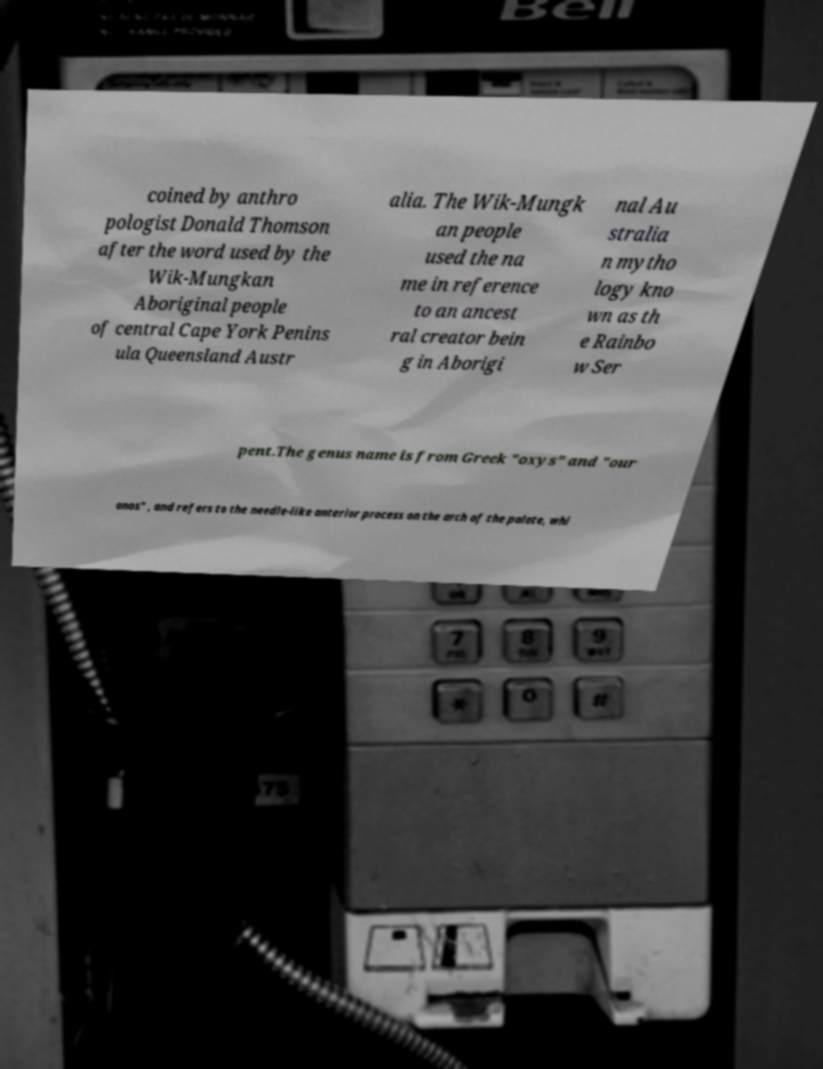Please read and relay the text visible in this image. What does it say? coined by anthro pologist Donald Thomson after the word used by the Wik-Mungkan Aboriginal people of central Cape York Penins ula Queensland Austr alia. The Wik-Mungk an people used the na me in reference to an ancest ral creator bein g in Aborigi nal Au stralia n mytho logy kno wn as th e Rainbo w Ser pent.The genus name is from Greek "oxys" and "our anos" , and refers to the needle-like anterior process on the arch of the palate, whi 